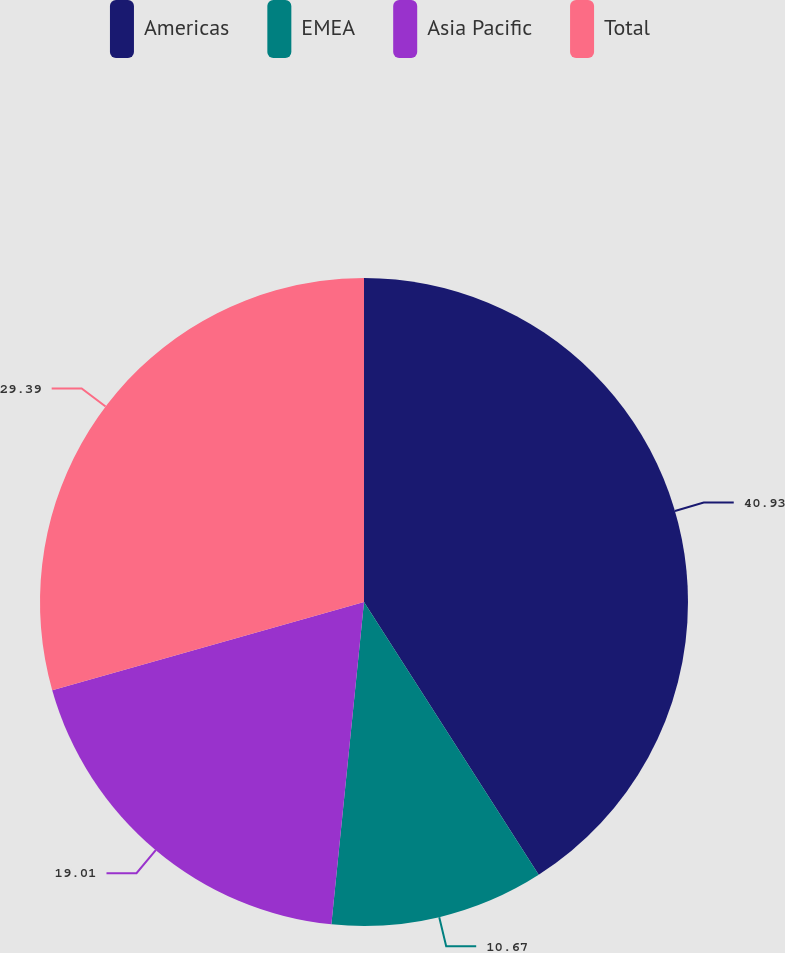Convert chart to OTSL. <chart><loc_0><loc_0><loc_500><loc_500><pie_chart><fcel>Americas<fcel>EMEA<fcel>Asia Pacific<fcel>Total<nl><fcel>40.94%<fcel>10.67%<fcel>19.01%<fcel>29.39%<nl></chart> 